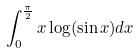<formula> <loc_0><loc_0><loc_500><loc_500>\int _ { 0 } ^ { \frac { \pi } { 2 } } x \log ( \sin x ) d x</formula> 